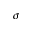Convert formula to latex. <formula><loc_0><loc_0><loc_500><loc_500>\sigma</formula> 